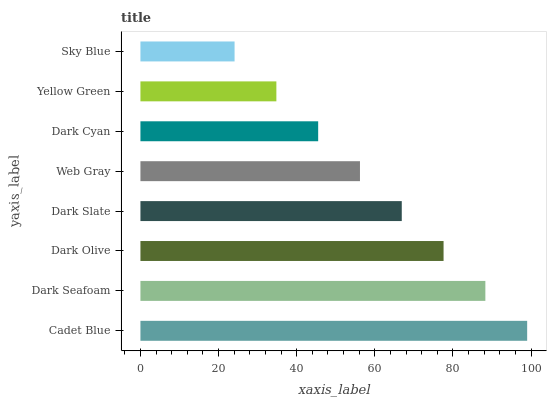Is Sky Blue the minimum?
Answer yes or no. Yes. Is Cadet Blue the maximum?
Answer yes or no. Yes. Is Dark Seafoam the minimum?
Answer yes or no. No. Is Dark Seafoam the maximum?
Answer yes or no. No. Is Cadet Blue greater than Dark Seafoam?
Answer yes or no. Yes. Is Dark Seafoam less than Cadet Blue?
Answer yes or no. Yes. Is Dark Seafoam greater than Cadet Blue?
Answer yes or no. No. Is Cadet Blue less than Dark Seafoam?
Answer yes or no. No. Is Dark Slate the high median?
Answer yes or no. Yes. Is Web Gray the low median?
Answer yes or no. Yes. Is Dark Seafoam the high median?
Answer yes or no. No. Is Yellow Green the low median?
Answer yes or no. No. 